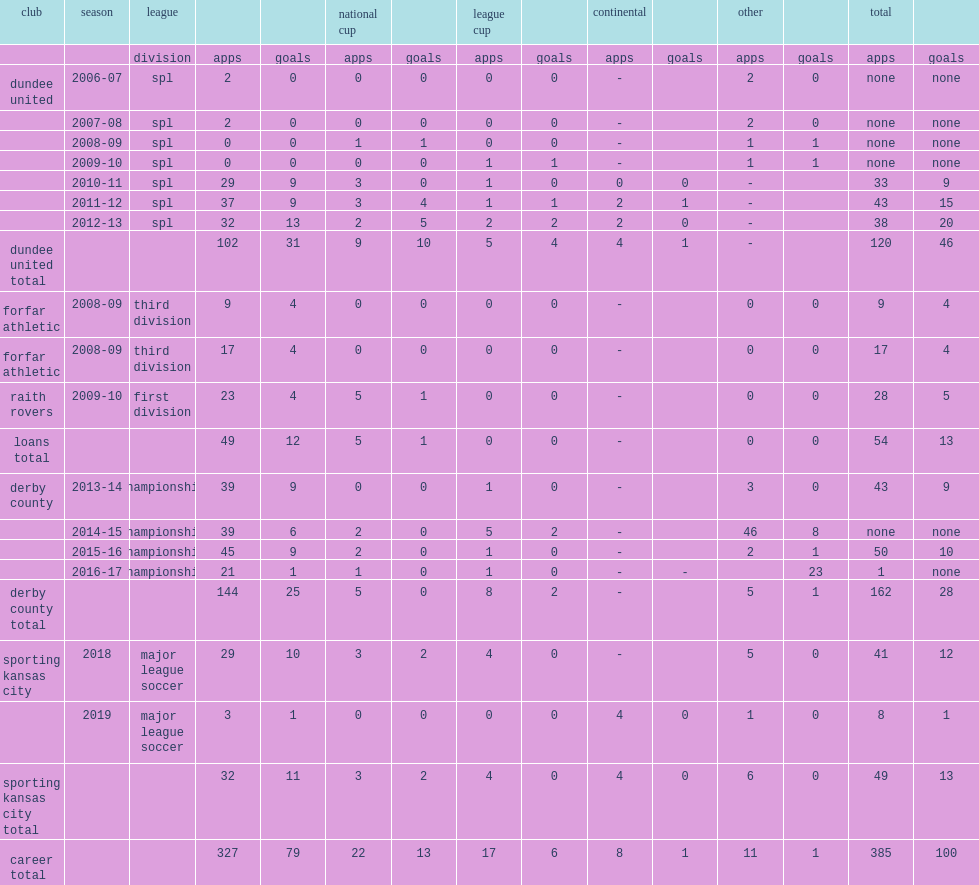In 2018, which club did russell sign with major league soccer? Sporting kansas city. 